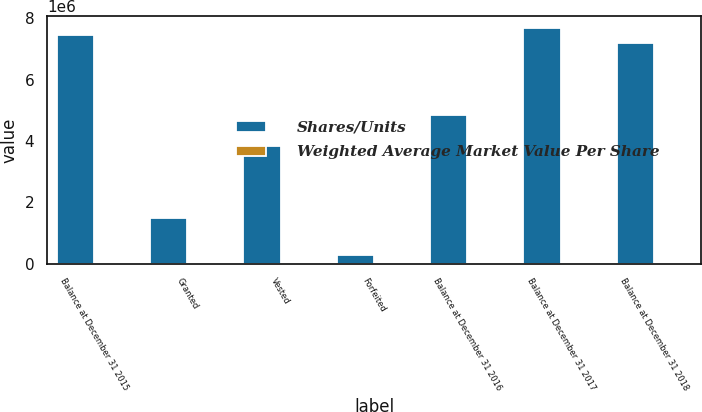Convert chart. <chart><loc_0><loc_0><loc_500><loc_500><stacked_bar_chart><ecel><fcel>Balance at December 31 2015<fcel>Granted<fcel>Vested<fcel>Forfeited<fcel>Balance at December 31 2016<fcel>Balance at December 31 2017<fcel>Balance at December 31 2018<nl><fcel>Shares/Units<fcel>7.46706e+06<fcel>1.49641e+06<fcel>3.84038e+06<fcel>279821<fcel>4.84327e+06<fcel>7.6771e+06<fcel>7.18236e+06<nl><fcel>Weighted Average Market Value Per Share<fcel>29.08<fcel>29.24<fcel>25.09<fcel>28.62<fcel>31.66<fcel>37.76<fcel>41.04<nl></chart> 